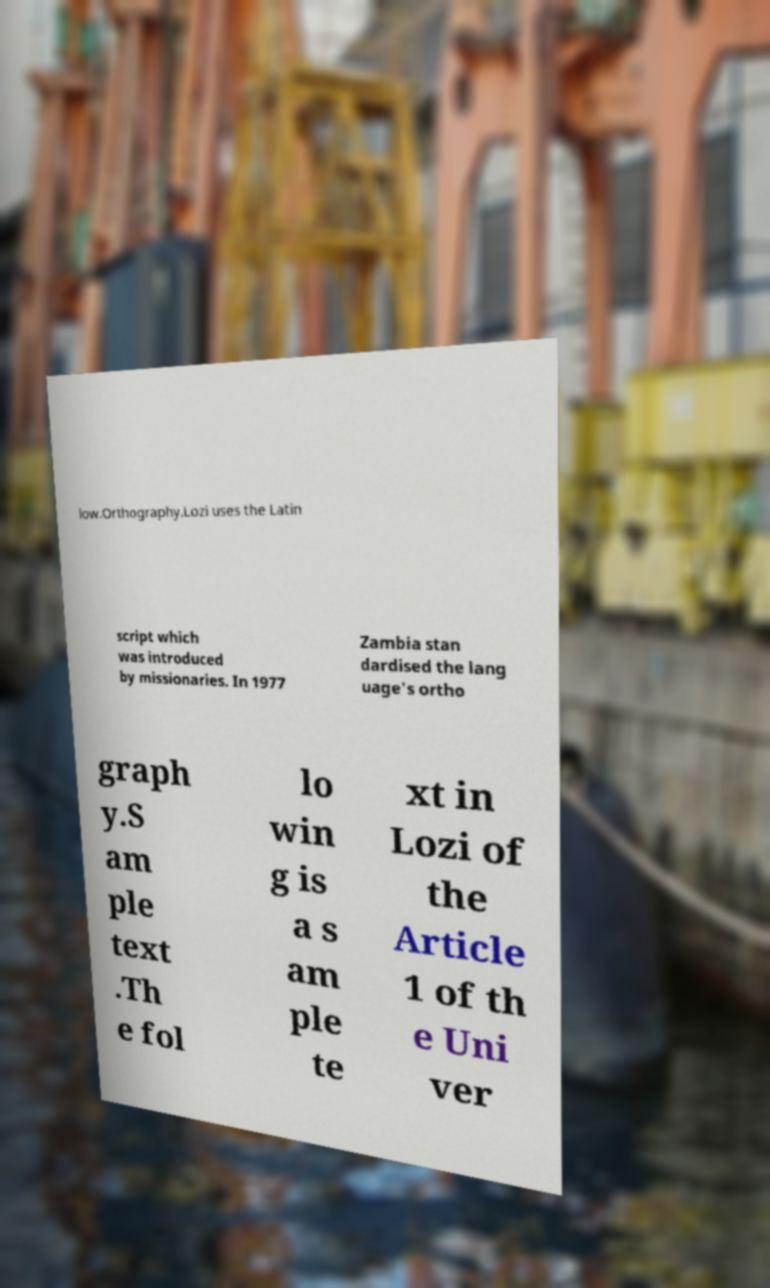Please read and relay the text visible in this image. What does it say? low.Orthography.Lozi uses the Latin script which was introduced by missionaries. In 1977 Zambia stan dardised the lang uage's ortho graph y.S am ple text .Th e fol lo win g is a s am ple te xt in Lozi of the Article 1 of th e Uni ver 